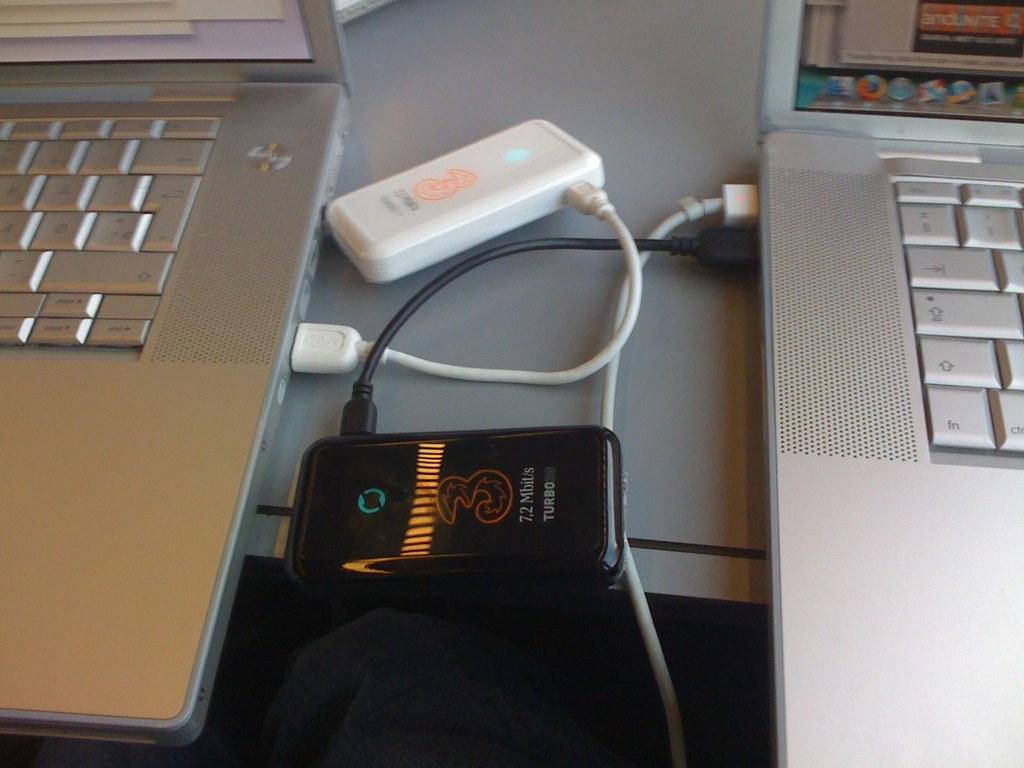How many megabits is mentioned?
Make the answer very short. 7.2. 